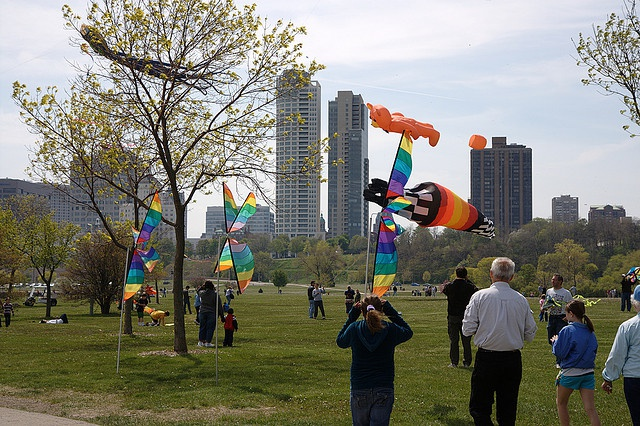Describe the objects in this image and their specific colors. I can see people in lavender, black, gray, and darkgray tones, people in lavender, black, olive, navy, and gray tones, people in lavender, black, darkgreen, gray, and maroon tones, people in lavender, black, navy, maroon, and olive tones, and kite in lavender, black, red, brown, and gray tones in this image. 